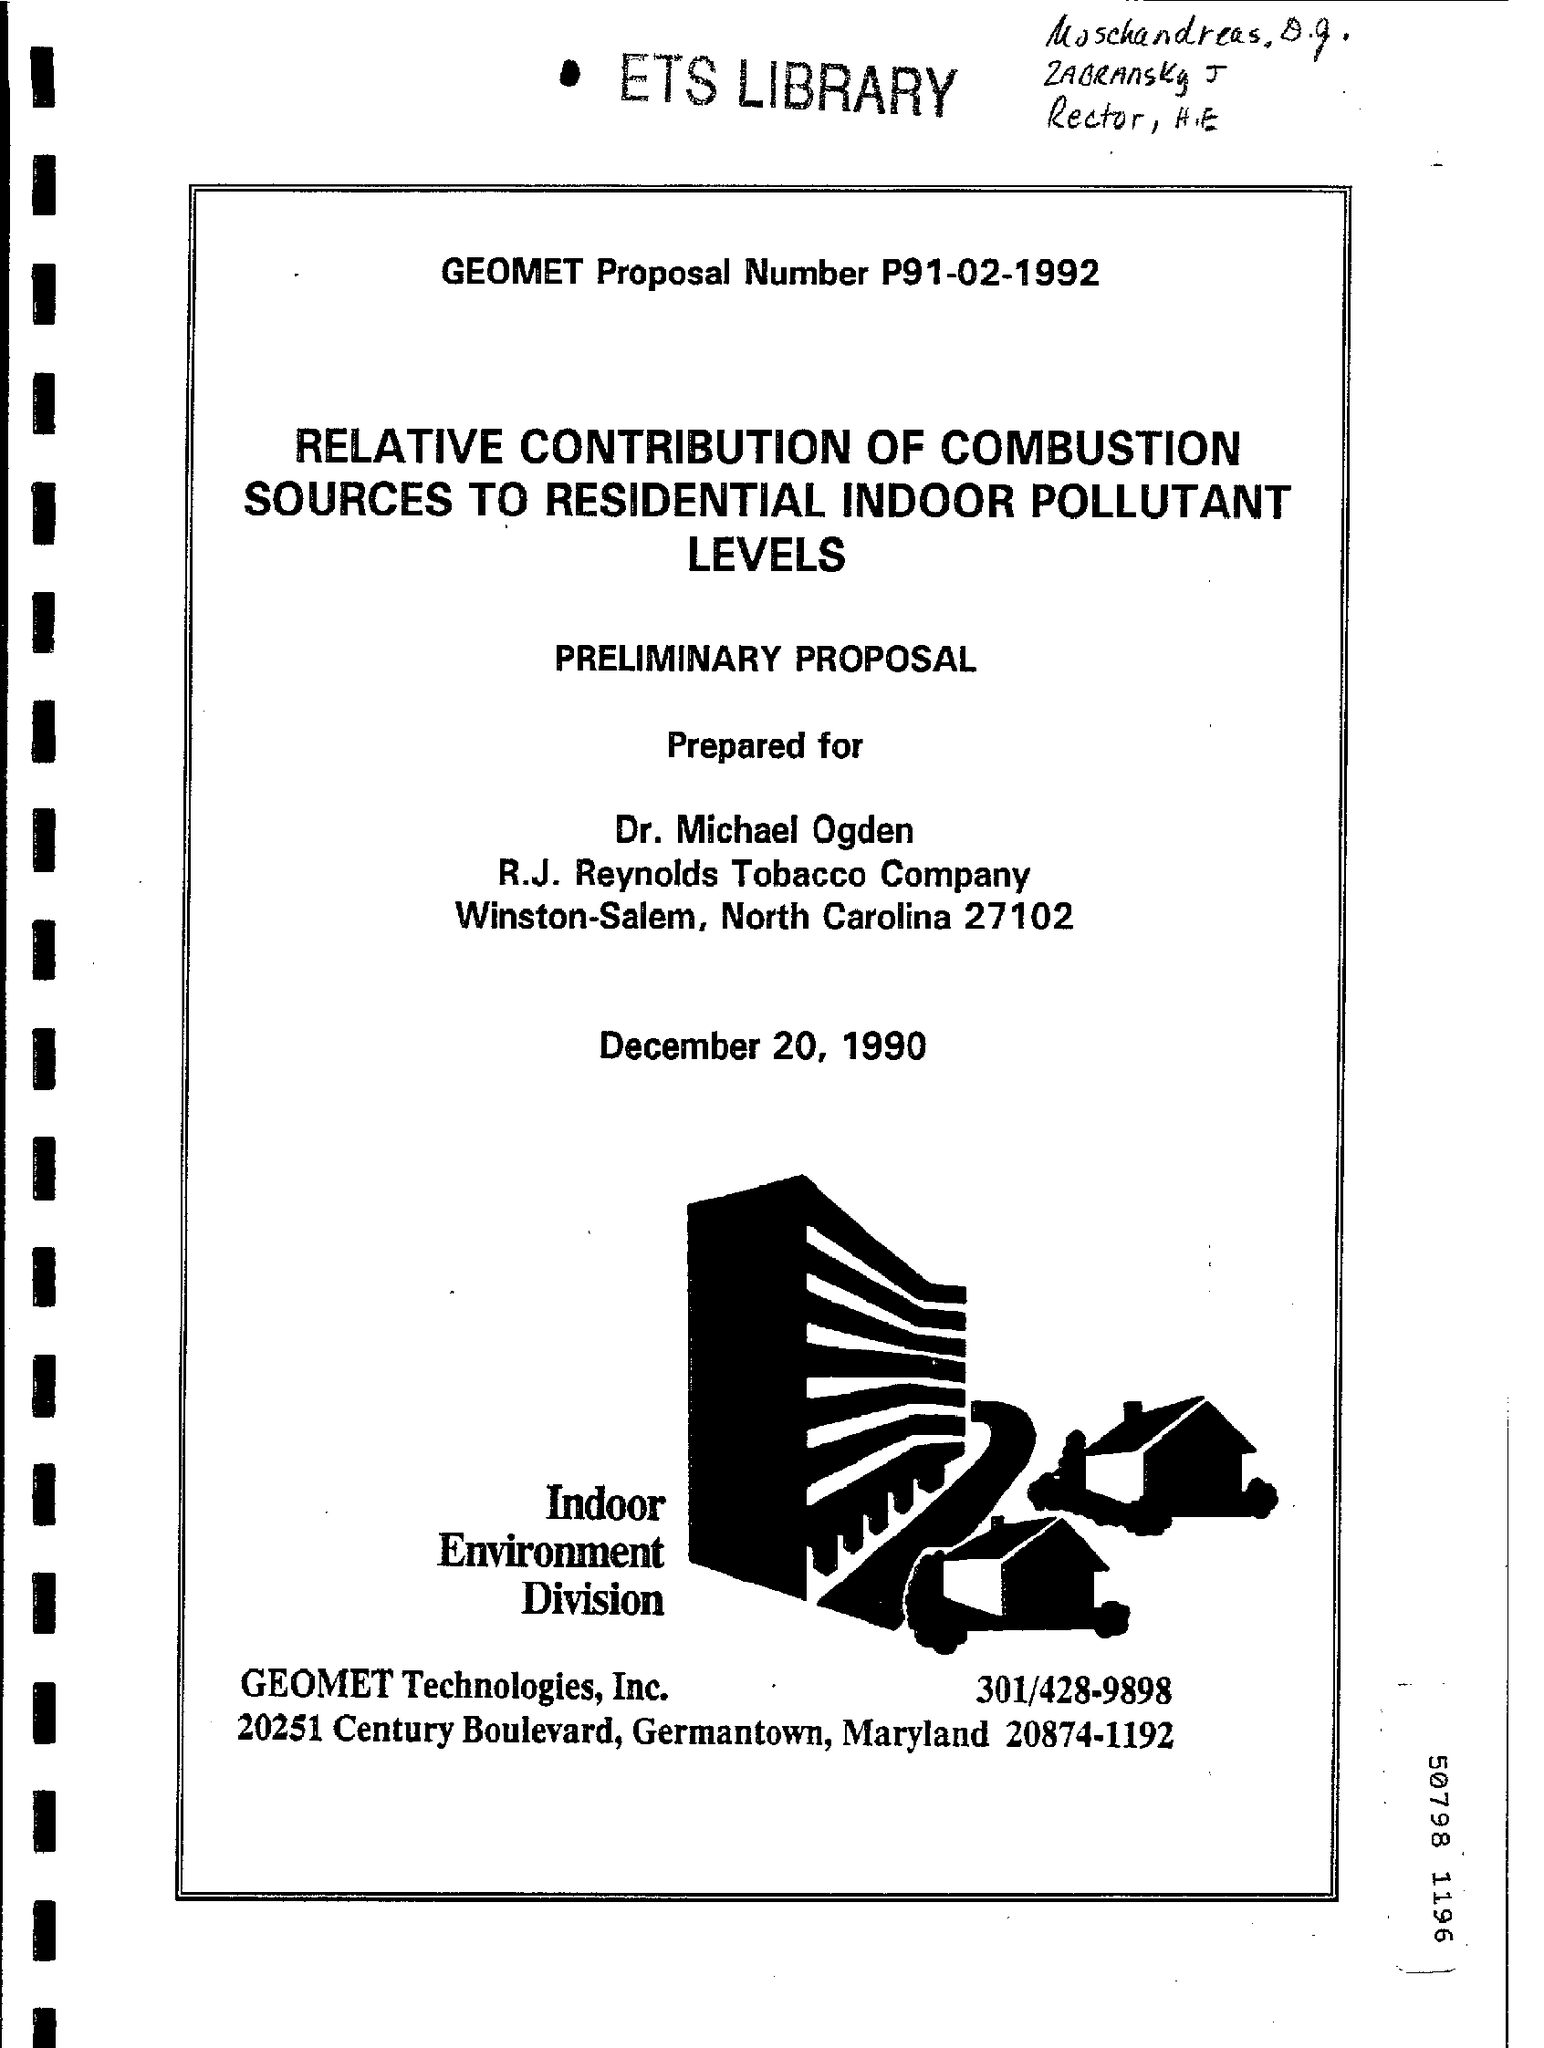Point out several critical features in this image. The GEOMET Proposal Number is P91-02-1992. 